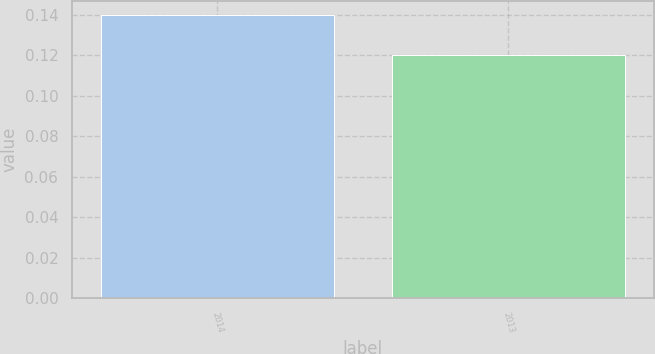Convert chart. <chart><loc_0><loc_0><loc_500><loc_500><bar_chart><fcel>2014<fcel>2013<nl><fcel>0.14<fcel>0.12<nl></chart> 